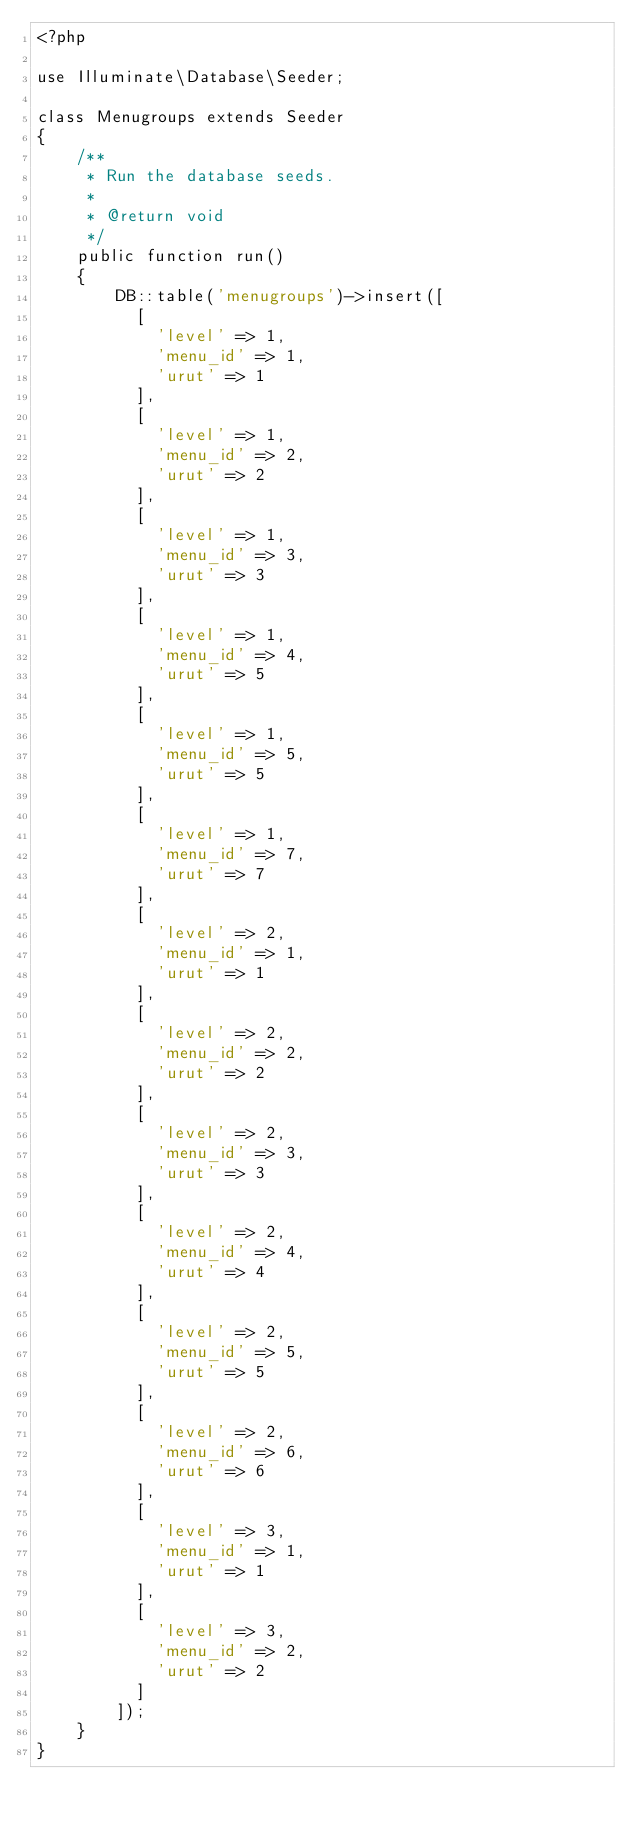<code> <loc_0><loc_0><loc_500><loc_500><_PHP_><?php

use Illuminate\Database\Seeder;

class Menugroups extends Seeder
{
    /**
     * Run the database seeds.
     *
     * @return void
     */
    public function run()
    {
        DB::table('menugroups')->insert([
          [
            'level' => 1,
            'menu_id' => 1,
            'urut' => 1
          ],
          [
            'level' => 1,
            'menu_id' => 2,
            'urut' => 2
          ],
          [
            'level' => 1,
            'menu_id' => 3,
            'urut' => 3
          ],
          [
            'level' => 1,
            'menu_id' => 4,
            'urut' => 5
          ],
          [
            'level' => 1,
            'menu_id' => 5,
            'urut' => 5
          ],
          [
            'level' => 1,
            'menu_id' => 7,
            'urut' => 7
          ],
          [
            'level' => 2,
            'menu_id' => 1,
            'urut' => 1
          ],
          [
            'level' => 2,
            'menu_id' => 2,
            'urut' => 2
          ],
          [
            'level' => 2,
            'menu_id' => 3,
            'urut' => 3
          ],
          [
            'level' => 2,
            'menu_id' => 4,
            'urut' => 4
          ],
          [
            'level' => 2,
            'menu_id' => 5,
            'urut' => 5
          ],
          [
            'level' => 2,
            'menu_id' => 6,
            'urut' => 6
          ],
          [
            'level' => 3,
            'menu_id' => 1,
            'urut' => 1
          ],
          [
            'level' => 3,
            'menu_id' => 2,
            'urut' => 2
          ]
        ]);
    }
}
</code> 